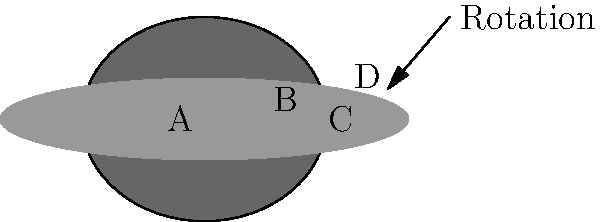In this layered representation of a black hole, identify the components labeled A, B, C, and D, considering how unconventional materials could be used to represent each layer's unique properties. How does the rotation of the black hole influence the shape of these components? To answer this question, let's break down the components of a black hole and relate them to the layered representation:

1. Component A (center, black): This represents the singularity, the core of the black hole where matter is compressed to infinite density. In mixed media, this could be represented by a dense, dark material like obsidian or black resin.

2. Component B (dark gray): This is the event horizon, the boundary beyond which nothing can escape the black hole's gravity. It could be represented by a semi-transparent, light-absorbing material like black acrylic or tinted glass.

3. Component C (medium gray, oval-shaped): This represents the ergosphere, a region outside the event horizon where space-time is dragged by the black hole's rotation. It could be depicted using a flexible, twisted material like wire mesh or elastic fabric.

4. Component D (light gray, disk-shaped): This is the accretion disk, where matter spirals into the black hole, heating up due to friction. It could be represented by layered, swirling materials like colored sand or textured paper.

The rotation of the black hole influences the shape of these components in the following ways:

1. The singularity (A) and event horizon (B) remain spherical regardless of rotation.
2. The ergosphere (C) becomes oblate (flattened at the poles) due to the black hole's spin, creating a distinct oval shape.
3. The accretion disk (D) forms a flattened disk perpendicular to the rotation axis, as depicted in the image.

This representation allows for a unique exploration of black hole physics through tactile and visual means, aligning with the mixed-media artist's approach to conveying complex scientific concepts.
Answer: A: Singularity, B: Event horizon, C: Ergosphere, D: Accretion disk. Rotation flattens ergosphere and shapes accretion disk. 